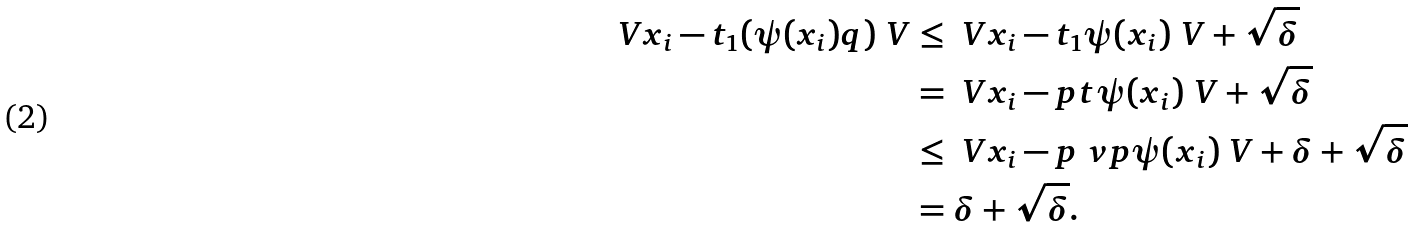<formula> <loc_0><loc_0><loc_500><loc_500>\ V x _ { i } - t _ { 1 } ( \psi ( x _ { i } ) q ) \ V & \leq \ V x _ { i } - t _ { 1 } \psi ( x _ { i } ) \ V + \sqrt { \delta } \\ & = \ V x _ { i } - p t \psi ( x _ { i } ) \ V + \sqrt { \delta } \\ & \leq \ V x _ { i } - p \ v p \psi ( x _ { i } ) \ V + \delta + \sqrt { \delta } \\ & = \delta + \sqrt { \delta } .</formula> 